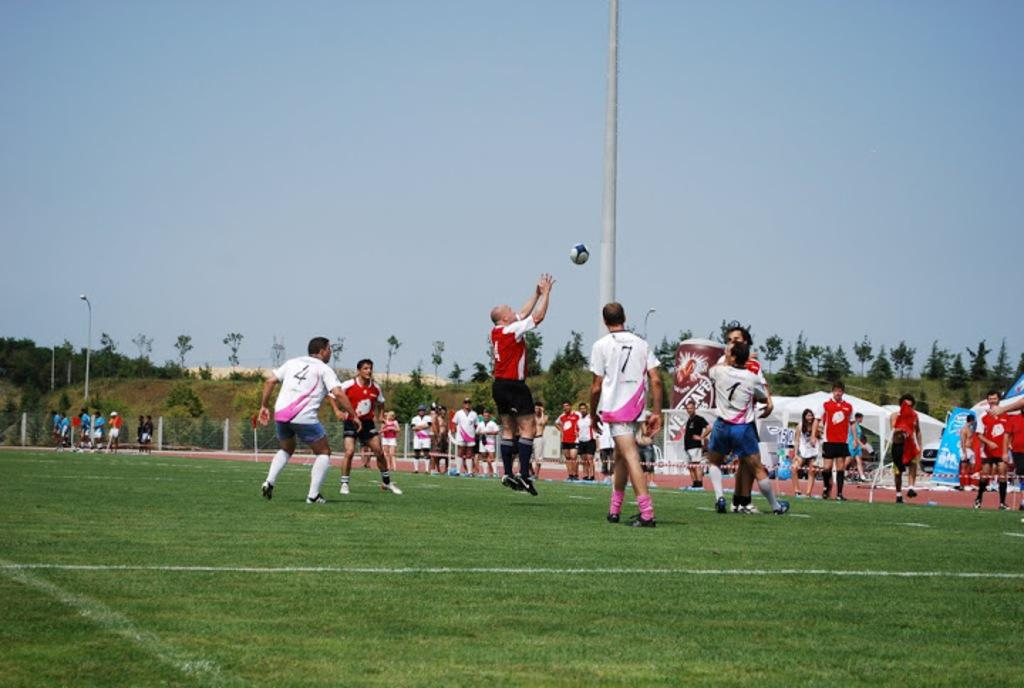<image>
Relay a brief, clear account of the picture shown. players in white and pink jerseys playing against others in red and white jerseys and a giant nescafe coffee cup in the background 